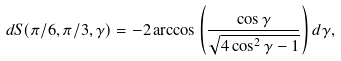Convert formula to latex. <formula><loc_0><loc_0><loc_500><loc_500>d S ( \pi / 6 , \pi / 3 , \gamma ) = - 2 \arccos \left ( \frac { \cos \gamma } { \sqrt { 4 \cos ^ { 2 } \gamma - 1 } } \right ) d \gamma ,</formula> 